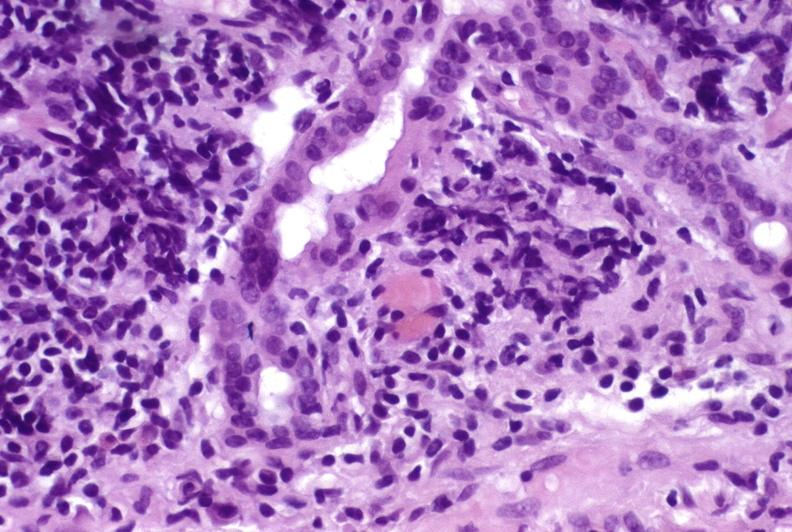does this image show recurrent hepatitis c virus?
Answer the question using a single word or phrase. Yes 